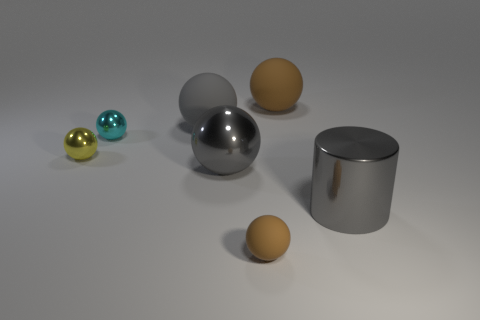Is there any other thing that is the same material as the yellow ball?
Ensure brevity in your answer.  Yes. What material is the gray thing that is to the right of the brown rubber thing behind the big matte object in front of the large brown ball?
Provide a succinct answer. Metal. Is there a big sphere left of the brown rubber sphere that is behind the large gray rubber thing?
Make the answer very short. Yes. What size is the gray rubber object?
Make the answer very short. Large. How many things are purple matte spheres or gray shiny balls?
Offer a terse response. 1. Do the gray thing on the right side of the tiny brown matte sphere and the big gray ball in front of the gray matte object have the same material?
Make the answer very short. Yes. What color is the cylinder that is made of the same material as the tiny yellow thing?
Provide a short and direct response. Gray. How many spheres are the same size as the gray rubber object?
Give a very brief answer. 2. What number of other objects are the same color as the big metallic ball?
Your answer should be very brief. 2. There is a large thing to the left of the gray metallic sphere; is it the same shape as the gray metallic object that is behind the metal cylinder?
Your answer should be very brief. Yes. 